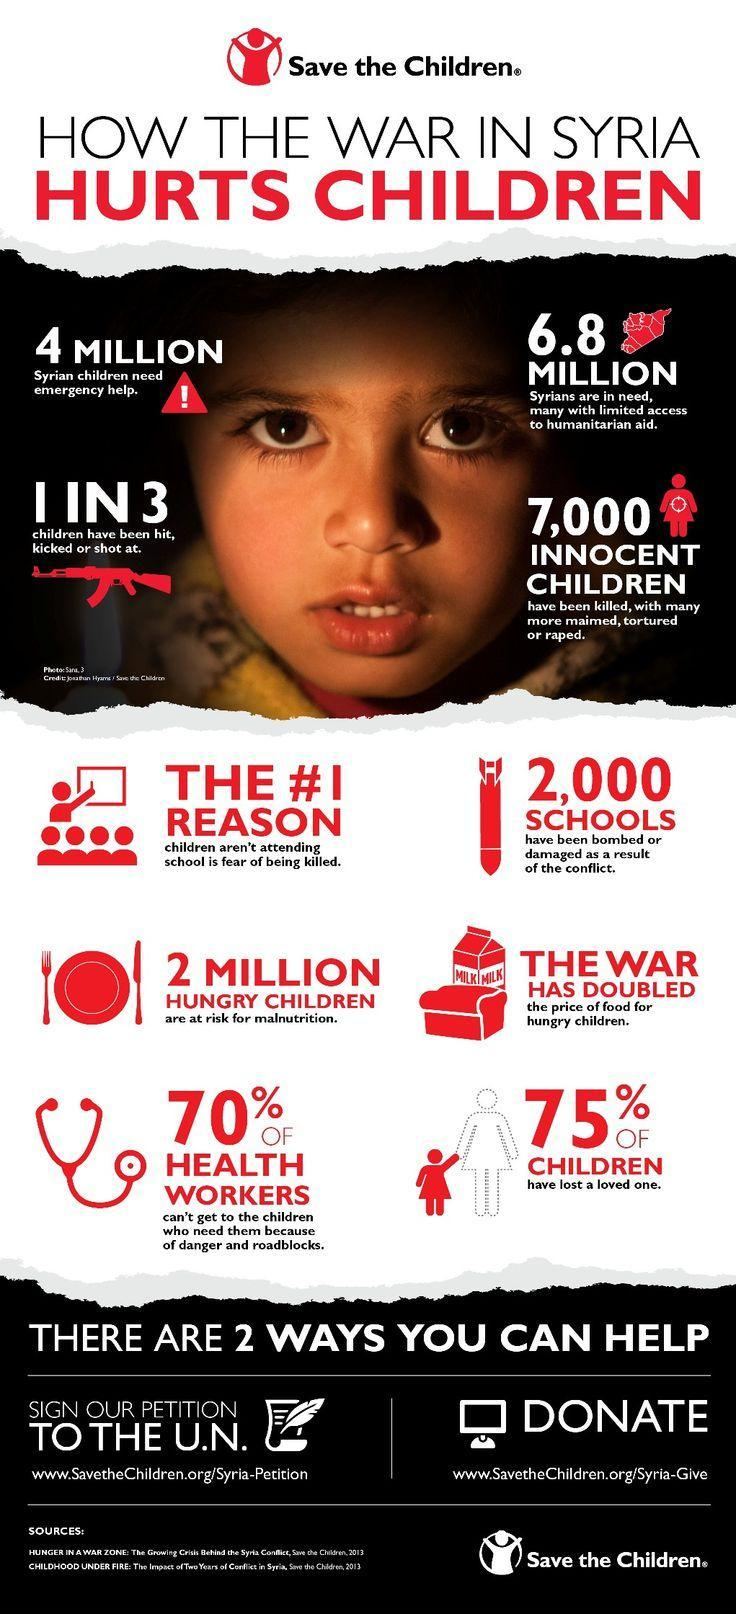What is the color in which the words "HURTS CHILDREN" is written at the top, red, black or blue?
Answer the question with a short phrase. red What is the color in which the words "HOW THE WAR IN SYRIA" is written at the top, red, black or white? black In Syria, how many children are at the risk of being undernourished? 2 million What is the color of gun icon given in this image, white, red or black? red How many times the word "million" is written in this image? 3 